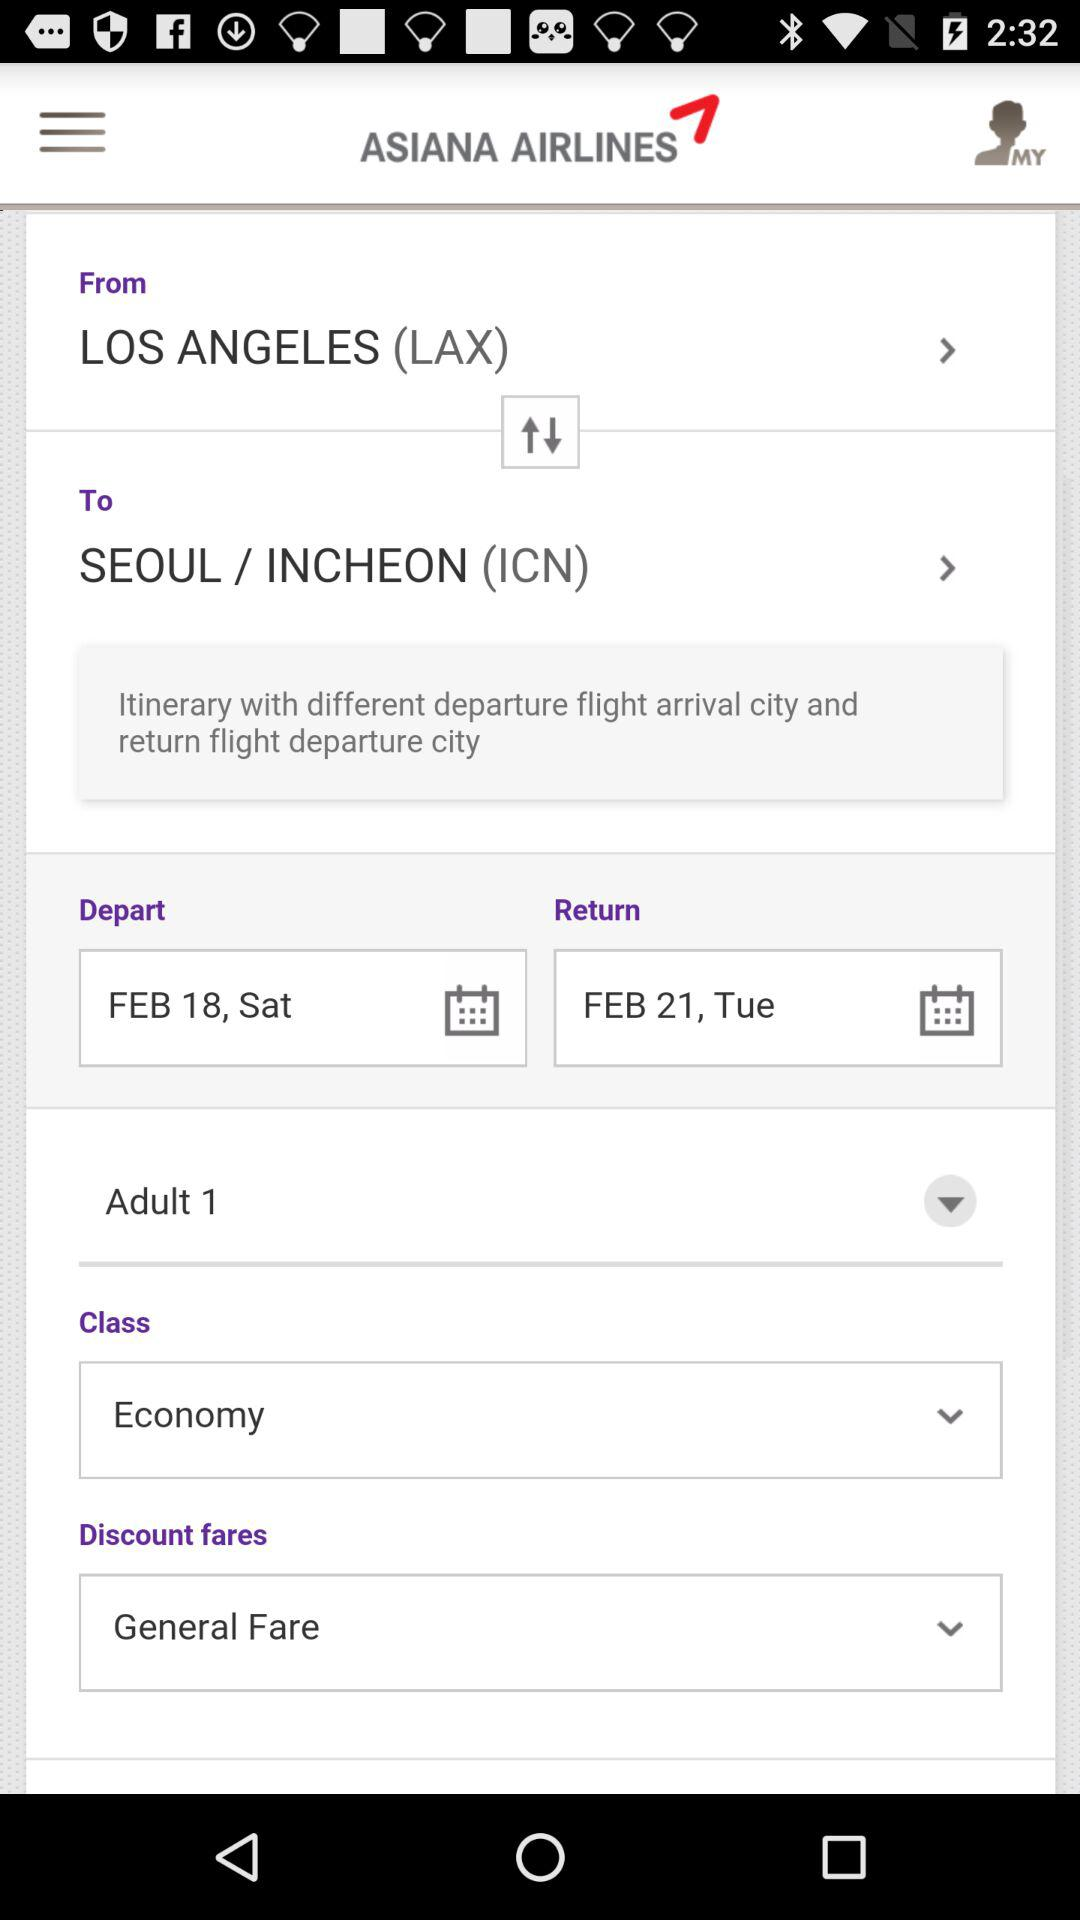What class is reserved? The reserved class is "Economy". 